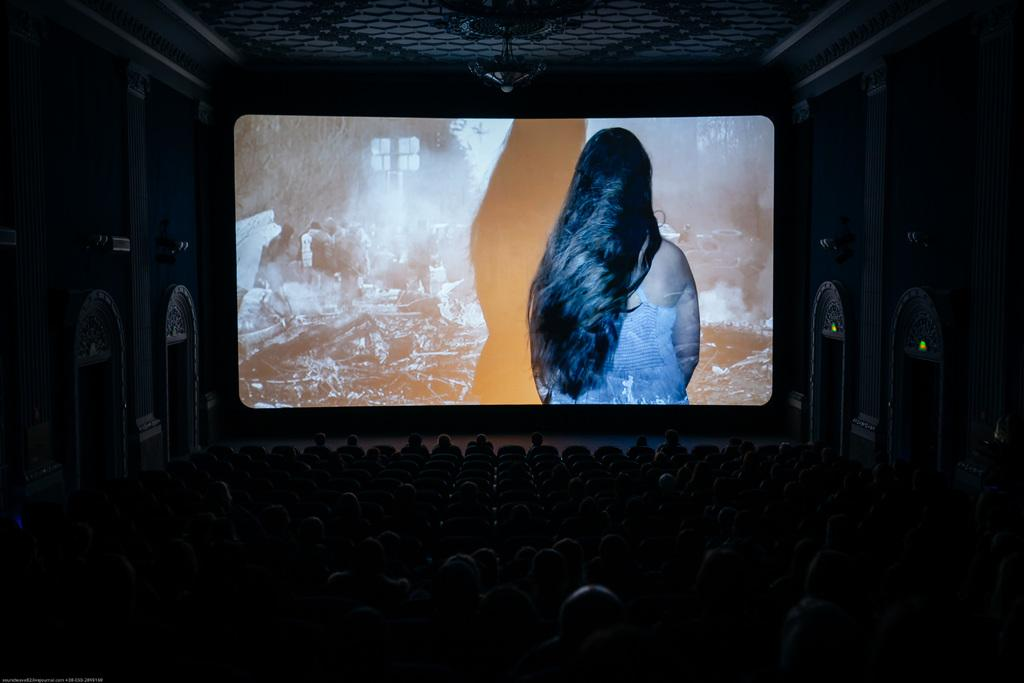What is the main object in the middle of the picture? There is a screen in the middle of the picture. What type of location does the setting resemble? The setting appears to be like a theater. How would you describe the lighting in the image? The surroundings are dark. How many books can be seen on the screen in the image? There are no books visible on the screen in the image. What trick is being performed on the screen in the image? There is no trick being performed on the screen in the image; it is simply a screen in a dark theater setting. 